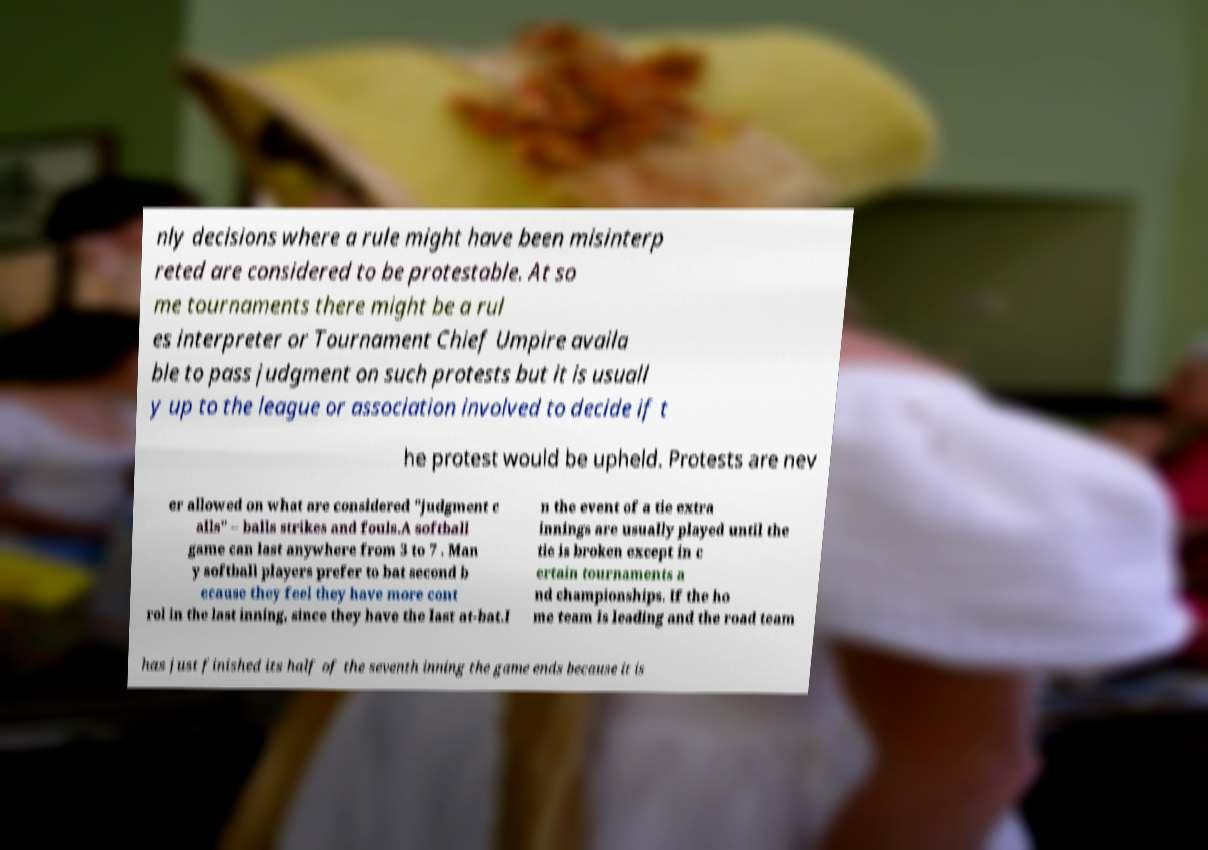Please identify and transcribe the text found in this image. nly decisions where a rule might have been misinterp reted are considered to be protestable. At so me tournaments there might be a rul es interpreter or Tournament Chief Umpire availa ble to pass judgment on such protests but it is usuall y up to the league or association involved to decide if t he protest would be upheld. Protests are nev er allowed on what are considered "judgment c alls" – balls strikes and fouls.A softball game can last anywhere from 3 to 7 . Man y softball players prefer to bat second b ecause they feel they have more cont rol in the last inning, since they have the last at-bat.I n the event of a tie extra innings are usually played until the tie is broken except in c ertain tournaments a nd championships. If the ho me team is leading and the road team has just finished its half of the seventh inning the game ends because it is 